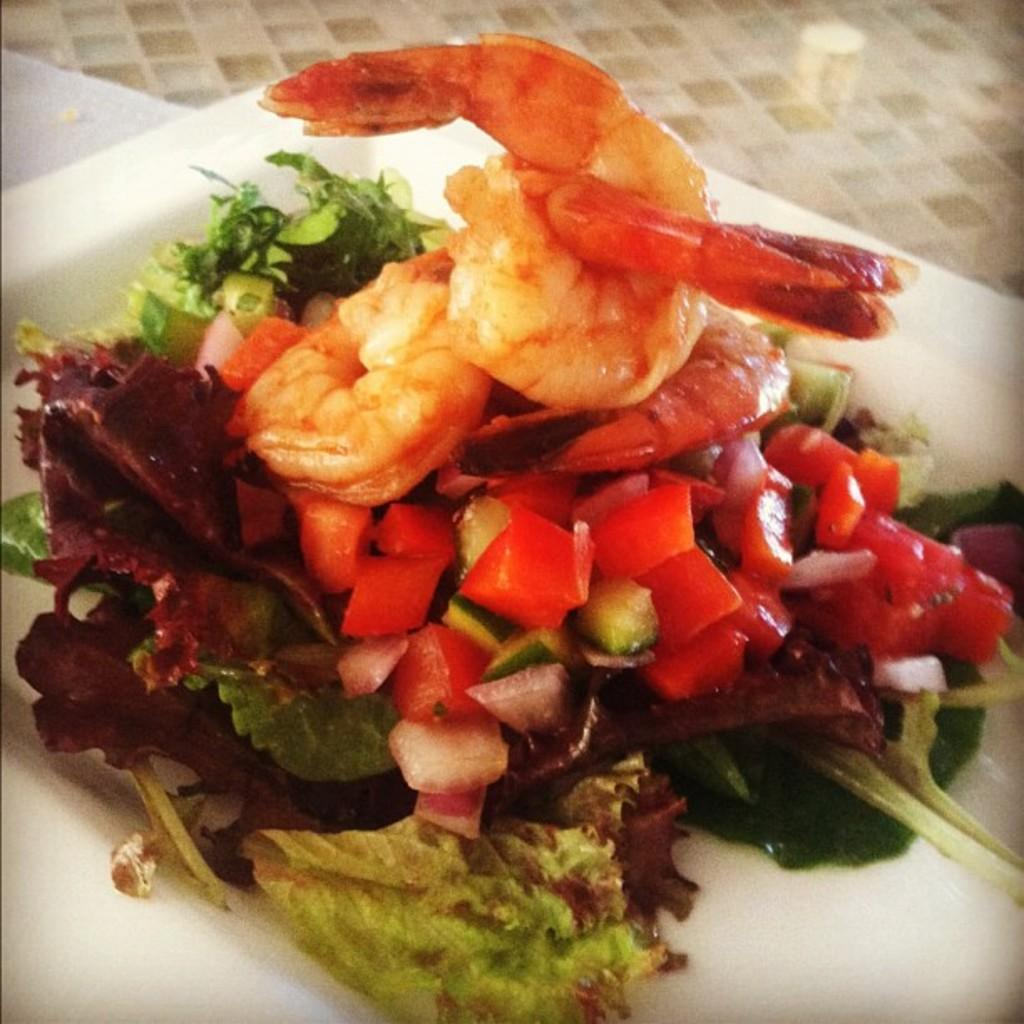What is on the plate that is visible in the image? There is food in a plate in the image. What other item can be seen in the image besides the plate of food? There is tissue paper on a surface in the image. Can you see the sea in the image? No, the sea is not present in the image. Is there any indication that the food on the plate is about to change? No, there is no indication that the food on the plate is about to change. 